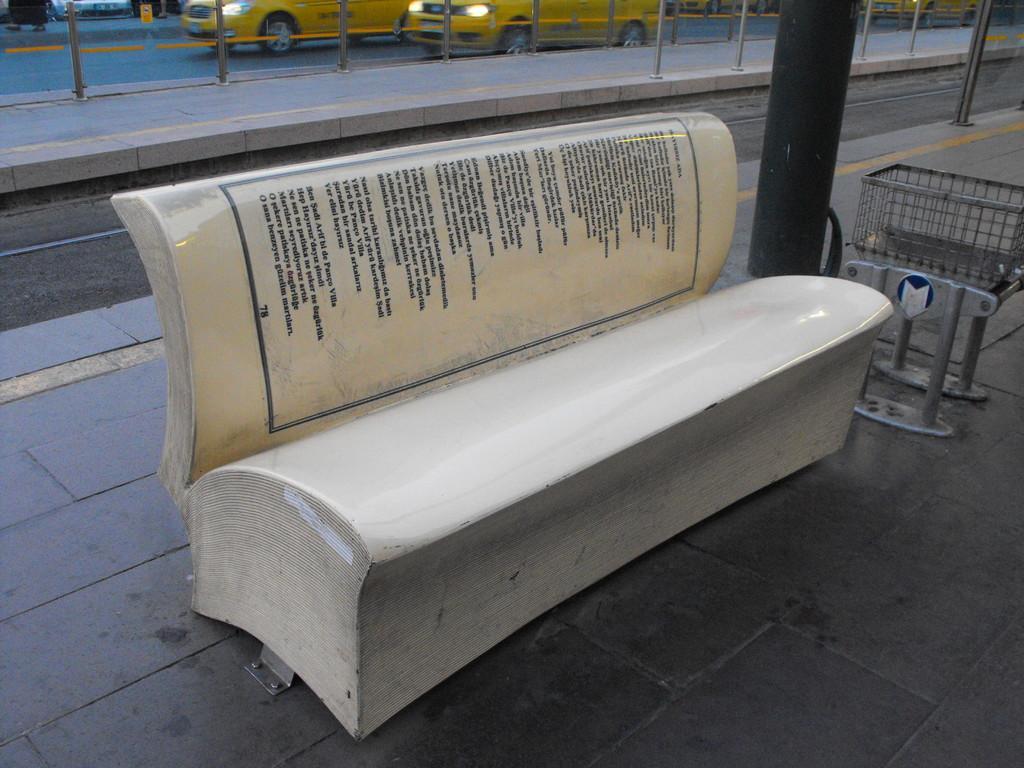Could you give a brief overview of what you see in this image? In the background we can see the vehicles, poles and the road. In this picture we can see a bench and there is some information on the bench. We can see few objects and a pillar. 